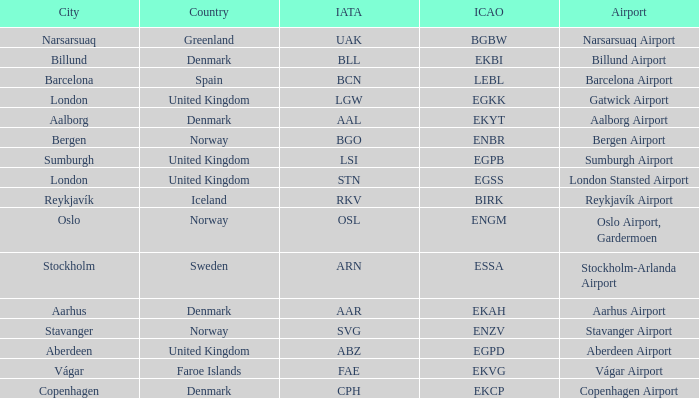What airport has an ICAP of BGBW? Narsarsuaq Airport. 